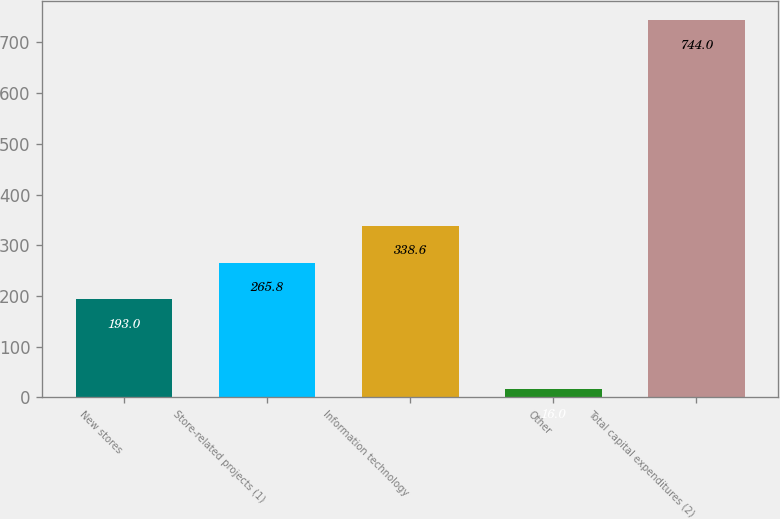Convert chart to OTSL. <chart><loc_0><loc_0><loc_500><loc_500><bar_chart><fcel>New stores<fcel>Store-related projects (1)<fcel>Information technology<fcel>Other<fcel>Total capital expenditures (2)<nl><fcel>193<fcel>265.8<fcel>338.6<fcel>16<fcel>744<nl></chart> 